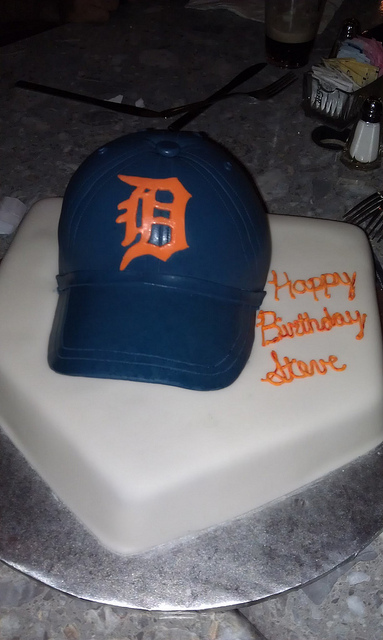Extract all visible text content from this image. Happy Birthday steve 